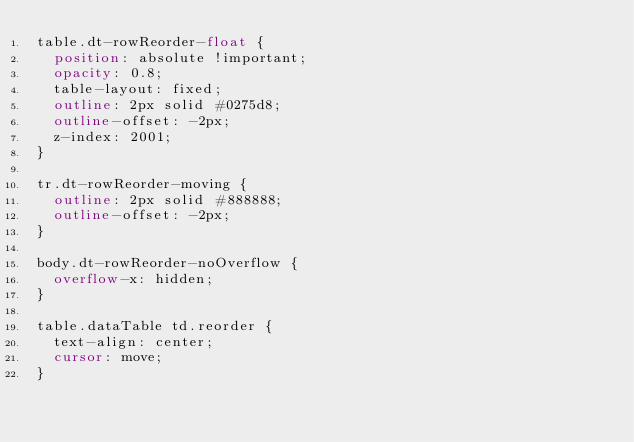Convert code to text. <code><loc_0><loc_0><loc_500><loc_500><_CSS_>table.dt-rowReorder-float {
  position: absolute !important;
  opacity: 0.8;
  table-layout: fixed;
  outline: 2px solid #0275d8;
  outline-offset: -2px;
  z-index: 2001;
}

tr.dt-rowReorder-moving {
  outline: 2px solid #888888;
  outline-offset: -2px;
}

body.dt-rowReorder-noOverflow {
  overflow-x: hidden;
}

table.dataTable td.reorder {
  text-align: center;
  cursor: move;
}
</code> 